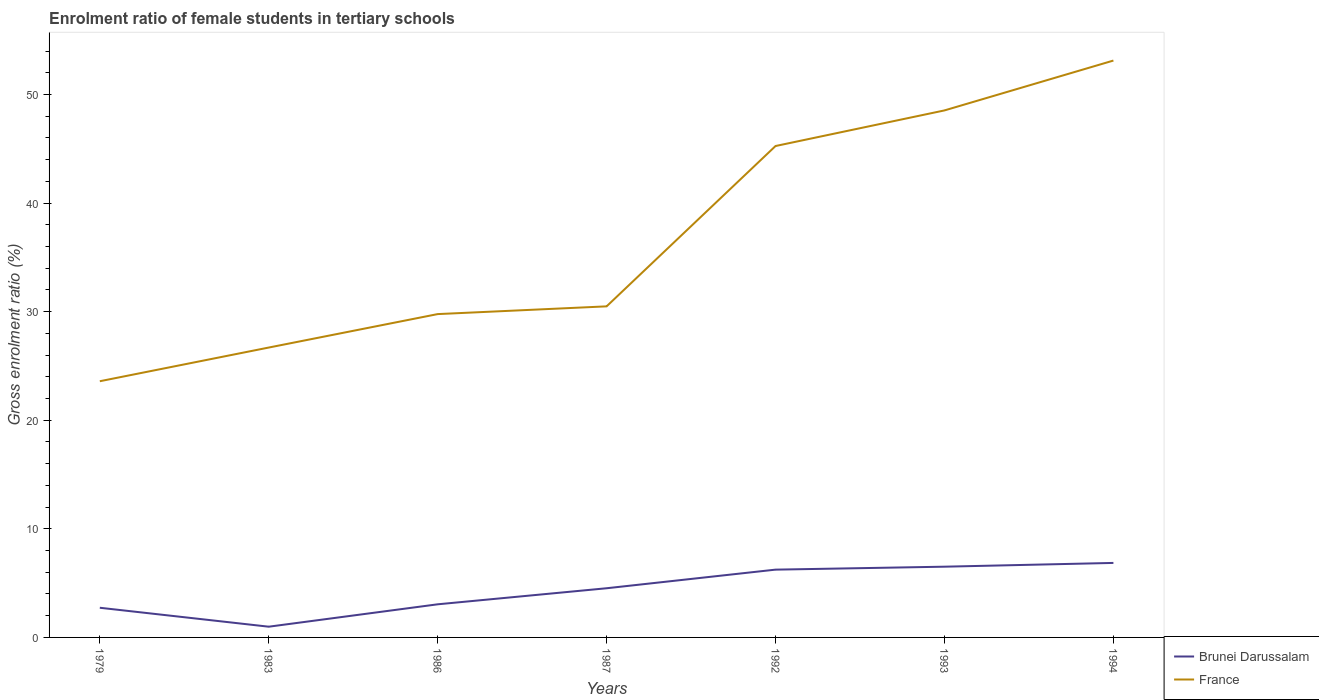How many different coloured lines are there?
Provide a succinct answer. 2. Is the number of lines equal to the number of legend labels?
Your answer should be compact. Yes. Across all years, what is the maximum enrolment ratio of female students in tertiary schools in Brunei Darussalam?
Provide a succinct answer. 0.99. In which year was the enrolment ratio of female students in tertiary schools in France maximum?
Offer a terse response. 1979. What is the total enrolment ratio of female students in tertiary schools in Brunei Darussalam in the graph?
Keep it short and to the point. -1.48. What is the difference between the highest and the second highest enrolment ratio of female students in tertiary schools in Brunei Darussalam?
Your response must be concise. 5.87. How many lines are there?
Offer a terse response. 2. What is the difference between two consecutive major ticks on the Y-axis?
Provide a short and direct response. 10. Are the values on the major ticks of Y-axis written in scientific E-notation?
Offer a terse response. No. Does the graph contain any zero values?
Provide a short and direct response. No. How many legend labels are there?
Your answer should be very brief. 2. How are the legend labels stacked?
Ensure brevity in your answer.  Vertical. What is the title of the graph?
Give a very brief answer. Enrolment ratio of female students in tertiary schools. Does "Slovak Republic" appear as one of the legend labels in the graph?
Your response must be concise. No. What is the Gross enrolment ratio (%) of Brunei Darussalam in 1979?
Give a very brief answer. 2.73. What is the Gross enrolment ratio (%) in France in 1979?
Make the answer very short. 23.59. What is the Gross enrolment ratio (%) in Brunei Darussalam in 1983?
Provide a succinct answer. 0.99. What is the Gross enrolment ratio (%) of France in 1983?
Your answer should be very brief. 26.7. What is the Gross enrolment ratio (%) in Brunei Darussalam in 1986?
Offer a terse response. 3.05. What is the Gross enrolment ratio (%) of France in 1986?
Provide a short and direct response. 29.78. What is the Gross enrolment ratio (%) in Brunei Darussalam in 1987?
Give a very brief answer. 4.53. What is the Gross enrolment ratio (%) of France in 1987?
Offer a very short reply. 30.49. What is the Gross enrolment ratio (%) of Brunei Darussalam in 1992?
Your answer should be compact. 6.24. What is the Gross enrolment ratio (%) in France in 1992?
Provide a succinct answer. 45.26. What is the Gross enrolment ratio (%) of Brunei Darussalam in 1993?
Keep it short and to the point. 6.51. What is the Gross enrolment ratio (%) in France in 1993?
Your answer should be compact. 48.53. What is the Gross enrolment ratio (%) of Brunei Darussalam in 1994?
Offer a very short reply. 6.86. What is the Gross enrolment ratio (%) in France in 1994?
Provide a short and direct response. 53.12. Across all years, what is the maximum Gross enrolment ratio (%) of Brunei Darussalam?
Your answer should be compact. 6.86. Across all years, what is the maximum Gross enrolment ratio (%) of France?
Offer a very short reply. 53.12. Across all years, what is the minimum Gross enrolment ratio (%) of Brunei Darussalam?
Keep it short and to the point. 0.99. Across all years, what is the minimum Gross enrolment ratio (%) of France?
Keep it short and to the point. 23.59. What is the total Gross enrolment ratio (%) of Brunei Darussalam in the graph?
Provide a succinct answer. 30.92. What is the total Gross enrolment ratio (%) in France in the graph?
Your answer should be very brief. 257.47. What is the difference between the Gross enrolment ratio (%) in Brunei Darussalam in 1979 and that in 1983?
Give a very brief answer. 1.74. What is the difference between the Gross enrolment ratio (%) in France in 1979 and that in 1983?
Your answer should be compact. -3.1. What is the difference between the Gross enrolment ratio (%) in Brunei Darussalam in 1979 and that in 1986?
Make the answer very short. -0.32. What is the difference between the Gross enrolment ratio (%) of France in 1979 and that in 1986?
Keep it short and to the point. -6.18. What is the difference between the Gross enrolment ratio (%) in Brunei Darussalam in 1979 and that in 1987?
Ensure brevity in your answer.  -1.8. What is the difference between the Gross enrolment ratio (%) of France in 1979 and that in 1987?
Keep it short and to the point. -6.89. What is the difference between the Gross enrolment ratio (%) in Brunei Darussalam in 1979 and that in 1992?
Provide a succinct answer. -3.51. What is the difference between the Gross enrolment ratio (%) in France in 1979 and that in 1992?
Provide a short and direct response. -21.66. What is the difference between the Gross enrolment ratio (%) of Brunei Darussalam in 1979 and that in 1993?
Your answer should be compact. -3.78. What is the difference between the Gross enrolment ratio (%) in France in 1979 and that in 1993?
Offer a terse response. -24.94. What is the difference between the Gross enrolment ratio (%) of Brunei Darussalam in 1979 and that in 1994?
Ensure brevity in your answer.  -4.13. What is the difference between the Gross enrolment ratio (%) in France in 1979 and that in 1994?
Ensure brevity in your answer.  -29.53. What is the difference between the Gross enrolment ratio (%) in Brunei Darussalam in 1983 and that in 1986?
Your answer should be very brief. -2.06. What is the difference between the Gross enrolment ratio (%) of France in 1983 and that in 1986?
Give a very brief answer. -3.08. What is the difference between the Gross enrolment ratio (%) of Brunei Darussalam in 1983 and that in 1987?
Give a very brief answer. -3.54. What is the difference between the Gross enrolment ratio (%) of France in 1983 and that in 1987?
Your response must be concise. -3.79. What is the difference between the Gross enrolment ratio (%) of Brunei Darussalam in 1983 and that in 1992?
Your answer should be compact. -5.25. What is the difference between the Gross enrolment ratio (%) of France in 1983 and that in 1992?
Ensure brevity in your answer.  -18.56. What is the difference between the Gross enrolment ratio (%) in Brunei Darussalam in 1983 and that in 1993?
Ensure brevity in your answer.  -5.53. What is the difference between the Gross enrolment ratio (%) of France in 1983 and that in 1993?
Your answer should be very brief. -21.84. What is the difference between the Gross enrolment ratio (%) in Brunei Darussalam in 1983 and that in 1994?
Your answer should be compact. -5.87. What is the difference between the Gross enrolment ratio (%) of France in 1983 and that in 1994?
Offer a terse response. -26.43. What is the difference between the Gross enrolment ratio (%) in Brunei Darussalam in 1986 and that in 1987?
Give a very brief answer. -1.48. What is the difference between the Gross enrolment ratio (%) of France in 1986 and that in 1987?
Ensure brevity in your answer.  -0.71. What is the difference between the Gross enrolment ratio (%) in Brunei Darussalam in 1986 and that in 1992?
Provide a short and direct response. -3.19. What is the difference between the Gross enrolment ratio (%) in France in 1986 and that in 1992?
Your answer should be very brief. -15.48. What is the difference between the Gross enrolment ratio (%) in Brunei Darussalam in 1986 and that in 1993?
Offer a very short reply. -3.46. What is the difference between the Gross enrolment ratio (%) in France in 1986 and that in 1993?
Offer a terse response. -18.76. What is the difference between the Gross enrolment ratio (%) of Brunei Darussalam in 1986 and that in 1994?
Offer a terse response. -3.81. What is the difference between the Gross enrolment ratio (%) of France in 1986 and that in 1994?
Make the answer very short. -23.35. What is the difference between the Gross enrolment ratio (%) of Brunei Darussalam in 1987 and that in 1992?
Offer a very short reply. -1.71. What is the difference between the Gross enrolment ratio (%) of France in 1987 and that in 1992?
Your answer should be compact. -14.77. What is the difference between the Gross enrolment ratio (%) in Brunei Darussalam in 1987 and that in 1993?
Give a very brief answer. -1.99. What is the difference between the Gross enrolment ratio (%) of France in 1987 and that in 1993?
Make the answer very short. -18.04. What is the difference between the Gross enrolment ratio (%) in Brunei Darussalam in 1987 and that in 1994?
Provide a succinct answer. -2.33. What is the difference between the Gross enrolment ratio (%) of France in 1987 and that in 1994?
Ensure brevity in your answer.  -22.64. What is the difference between the Gross enrolment ratio (%) in Brunei Darussalam in 1992 and that in 1993?
Provide a short and direct response. -0.27. What is the difference between the Gross enrolment ratio (%) of France in 1992 and that in 1993?
Your answer should be compact. -3.28. What is the difference between the Gross enrolment ratio (%) of Brunei Darussalam in 1992 and that in 1994?
Provide a short and direct response. -0.62. What is the difference between the Gross enrolment ratio (%) of France in 1992 and that in 1994?
Ensure brevity in your answer.  -7.87. What is the difference between the Gross enrolment ratio (%) of Brunei Darussalam in 1993 and that in 1994?
Give a very brief answer. -0.35. What is the difference between the Gross enrolment ratio (%) in France in 1993 and that in 1994?
Make the answer very short. -4.59. What is the difference between the Gross enrolment ratio (%) in Brunei Darussalam in 1979 and the Gross enrolment ratio (%) in France in 1983?
Provide a succinct answer. -23.96. What is the difference between the Gross enrolment ratio (%) in Brunei Darussalam in 1979 and the Gross enrolment ratio (%) in France in 1986?
Your response must be concise. -27.04. What is the difference between the Gross enrolment ratio (%) of Brunei Darussalam in 1979 and the Gross enrolment ratio (%) of France in 1987?
Provide a short and direct response. -27.76. What is the difference between the Gross enrolment ratio (%) of Brunei Darussalam in 1979 and the Gross enrolment ratio (%) of France in 1992?
Give a very brief answer. -42.52. What is the difference between the Gross enrolment ratio (%) in Brunei Darussalam in 1979 and the Gross enrolment ratio (%) in France in 1993?
Your answer should be compact. -45.8. What is the difference between the Gross enrolment ratio (%) of Brunei Darussalam in 1979 and the Gross enrolment ratio (%) of France in 1994?
Offer a very short reply. -50.39. What is the difference between the Gross enrolment ratio (%) of Brunei Darussalam in 1983 and the Gross enrolment ratio (%) of France in 1986?
Offer a very short reply. -28.79. What is the difference between the Gross enrolment ratio (%) in Brunei Darussalam in 1983 and the Gross enrolment ratio (%) in France in 1987?
Provide a succinct answer. -29.5. What is the difference between the Gross enrolment ratio (%) in Brunei Darussalam in 1983 and the Gross enrolment ratio (%) in France in 1992?
Make the answer very short. -44.27. What is the difference between the Gross enrolment ratio (%) in Brunei Darussalam in 1983 and the Gross enrolment ratio (%) in France in 1993?
Ensure brevity in your answer.  -47.54. What is the difference between the Gross enrolment ratio (%) in Brunei Darussalam in 1983 and the Gross enrolment ratio (%) in France in 1994?
Offer a very short reply. -52.14. What is the difference between the Gross enrolment ratio (%) of Brunei Darussalam in 1986 and the Gross enrolment ratio (%) of France in 1987?
Provide a succinct answer. -27.44. What is the difference between the Gross enrolment ratio (%) of Brunei Darussalam in 1986 and the Gross enrolment ratio (%) of France in 1992?
Give a very brief answer. -42.2. What is the difference between the Gross enrolment ratio (%) in Brunei Darussalam in 1986 and the Gross enrolment ratio (%) in France in 1993?
Ensure brevity in your answer.  -45.48. What is the difference between the Gross enrolment ratio (%) in Brunei Darussalam in 1986 and the Gross enrolment ratio (%) in France in 1994?
Provide a short and direct response. -50.07. What is the difference between the Gross enrolment ratio (%) in Brunei Darussalam in 1987 and the Gross enrolment ratio (%) in France in 1992?
Make the answer very short. -40.73. What is the difference between the Gross enrolment ratio (%) in Brunei Darussalam in 1987 and the Gross enrolment ratio (%) in France in 1993?
Offer a very short reply. -44. What is the difference between the Gross enrolment ratio (%) in Brunei Darussalam in 1987 and the Gross enrolment ratio (%) in France in 1994?
Provide a short and direct response. -48.6. What is the difference between the Gross enrolment ratio (%) of Brunei Darussalam in 1992 and the Gross enrolment ratio (%) of France in 1993?
Your response must be concise. -42.29. What is the difference between the Gross enrolment ratio (%) of Brunei Darussalam in 1992 and the Gross enrolment ratio (%) of France in 1994?
Ensure brevity in your answer.  -46.88. What is the difference between the Gross enrolment ratio (%) in Brunei Darussalam in 1993 and the Gross enrolment ratio (%) in France in 1994?
Your response must be concise. -46.61. What is the average Gross enrolment ratio (%) of Brunei Darussalam per year?
Keep it short and to the point. 4.42. What is the average Gross enrolment ratio (%) in France per year?
Offer a very short reply. 36.78. In the year 1979, what is the difference between the Gross enrolment ratio (%) in Brunei Darussalam and Gross enrolment ratio (%) in France?
Your response must be concise. -20.86. In the year 1983, what is the difference between the Gross enrolment ratio (%) in Brunei Darussalam and Gross enrolment ratio (%) in France?
Offer a terse response. -25.71. In the year 1986, what is the difference between the Gross enrolment ratio (%) in Brunei Darussalam and Gross enrolment ratio (%) in France?
Offer a terse response. -26.73. In the year 1987, what is the difference between the Gross enrolment ratio (%) in Brunei Darussalam and Gross enrolment ratio (%) in France?
Your response must be concise. -25.96. In the year 1992, what is the difference between the Gross enrolment ratio (%) of Brunei Darussalam and Gross enrolment ratio (%) of France?
Your response must be concise. -39.01. In the year 1993, what is the difference between the Gross enrolment ratio (%) in Brunei Darussalam and Gross enrolment ratio (%) in France?
Make the answer very short. -42.02. In the year 1994, what is the difference between the Gross enrolment ratio (%) of Brunei Darussalam and Gross enrolment ratio (%) of France?
Provide a succinct answer. -46.26. What is the ratio of the Gross enrolment ratio (%) of Brunei Darussalam in 1979 to that in 1983?
Ensure brevity in your answer.  2.76. What is the ratio of the Gross enrolment ratio (%) of France in 1979 to that in 1983?
Offer a very short reply. 0.88. What is the ratio of the Gross enrolment ratio (%) of Brunei Darussalam in 1979 to that in 1986?
Provide a succinct answer. 0.9. What is the ratio of the Gross enrolment ratio (%) in France in 1979 to that in 1986?
Your answer should be very brief. 0.79. What is the ratio of the Gross enrolment ratio (%) of Brunei Darussalam in 1979 to that in 1987?
Provide a succinct answer. 0.6. What is the ratio of the Gross enrolment ratio (%) in France in 1979 to that in 1987?
Your answer should be very brief. 0.77. What is the ratio of the Gross enrolment ratio (%) in Brunei Darussalam in 1979 to that in 1992?
Your answer should be compact. 0.44. What is the ratio of the Gross enrolment ratio (%) of France in 1979 to that in 1992?
Provide a succinct answer. 0.52. What is the ratio of the Gross enrolment ratio (%) of Brunei Darussalam in 1979 to that in 1993?
Ensure brevity in your answer.  0.42. What is the ratio of the Gross enrolment ratio (%) in France in 1979 to that in 1993?
Your response must be concise. 0.49. What is the ratio of the Gross enrolment ratio (%) in Brunei Darussalam in 1979 to that in 1994?
Offer a very short reply. 0.4. What is the ratio of the Gross enrolment ratio (%) of France in 1979 to that in 1994?
Your answer should be compact. 0.44. What is the ratio of the Gross enrolment ratio (%) of Brunei Darussalam in 1983 to that in 1986?
Give a very brief answer. 0.32. What is the ratio of the Gross enrolment ratio (%) in France in 1983 to that in 1986?
Ensure brevity in your answer.  0.9. What is the ratio of the Gross enrolment ratio (%) in Brunei Darussalam in 1983 to that in 1987?
Offer a very short reply. 0.22. What is the ratio of the Gross enrolment ratio (%) of France in 1983 to that in 1987?
Make the answer very short. 0.88. What is the ratio of the Gross enrolment ratio (%) of Brunei Darussalam in 1983 to that in 1992?
Offer a terse response. 0.16. What is the ratio of the Gross enrolment ratio (%) of France in 1983 to that in 1992?
Provide a succinct answer. 0.59. What is the ratio of the Gross enrolment ratio (%) in Brunei Darussalam in 1983 to that in 1993?
Provide a short and direct response. 0.15. What is the ratio of the Gross enrolment ratio (%) of France in 1983 to that in 1993?
Your answer should be compact. 0.55. What is the ratio of the Gross enrolment ratio (%) in Brunei Darussalam in 1983 to that in 1994?
Your answer should be very brief. 0.14. What is the ratio of the Gross enrolment ratio (%) of France in 1983 to that in 1994?
Offer a terse response. 0.5. What is the ratio of the Gross enrolment ratio (%) in Brunei Darussalam in 1986 to that in 1987?
Your answer should be very brief. 0.67. What is the ratio of the Gross enrolment ratio (%) in France in 1986 to that in 1987?
Make the answer very short. 0.98. What is the ratio of the Gross enrolment ratio (%) in Brunei Darussalam in 1986 to that in 1992?
Provide a short and direct response. 0.49. What is the ratio of the Gross enrolment ratio (%) in France in 1986 to that in 1992?
Offer a terse response. 0.66. What is the ratio of the Gross enrolment ratio (%) in Brunei Darussalam in 1986 to that in 1993?
Ensure brevity in your answer.  0.47. What is the ratio of the Gross enrolment ratio (%) in France in 1986 to that in 1993?
Provide a succinct answer. 0.61. What is the ratio of the Gross enrolment ratio (%) of Brunei Darussalam in 1986 to that in 1994?
Keep it short and to the point. 0.44. What is the ratio of the Gross enrolment ratio (%) of France in 1986 to that in 1994?
Offer a terse response. 0.56. What is the ratio of the Gross enrolment ratio (%) in Brunei Darussalam in 1987 to that in 1992?
Provide a succinct answer. 0.73. What is the ratio of the Gross enrolment ratio (%) of France in 1987 to that in 1992?
Provide a succinct answer. 0.67. What is the ratio of the Gross enrolment ratio (%) of Brunei Darussalam in 1987 to that in 1993?
Your response must be concise. 0.7. What is the ratio of the Gross enrolment ratio (%) in France in 1987 to that in 1993?
Your answer should be compact. 0.63. What is the ratio of the Gross enrolment ratio (%) of Brunei Darussalam in 1987 to that in 1994?
Give a very brief answer. 0.66. What is the ratio of the Gross enrolment ratio (%) in France in 1987 to that in 1994?
Give a very brief answer. 0.57. What is the ratio of the Gross enrolment ratio (%) of Brunei Darussalam in 1992 to that in 1993?
Your response must be concise. 0.96. What is the ratio of the Gross enrolment ratio (%) of France in 1992 to that in 1993?
Your answer should be very brief. 0.93. What is the ratio of the Gross enrolment ratio (%) in Brunei Darussalam in 1992 to that in 1994?
Offer a terse response. 0.91. What is the ratio of the Gross enrolment ratio (%) in France in 1992 to that in 1994?
Your answer should be compact. 0.85. What is the ratio of the Gross enrolment ratio (%) of Brunei Darussalam in 1993 to that in 1994?
Keep it short and to the point. 0.95. What is the ratio of the Gross enrolment ratio (%) of France in 1993 to that in 1994?
Make the answer very short. 0.91. What is the difference between the highest and the second highest Gross enrolment ratio (%) of Brunei Darussalam?
Offer a very short reply. 0.35. What is the difference between the highest and the second highest Gross enrolment ratio (%) of France?
Keep it short and to the point. 4.59. What is the difference between the highest and the lowest Gross enrolment ratio (%) in Brunei Darussalam?
Provide a succinct answer. 5.87. What is the difference between the highest and the lowest Gross enrolment ratio (%) of France?
Your answer should be compact. 29.53. 